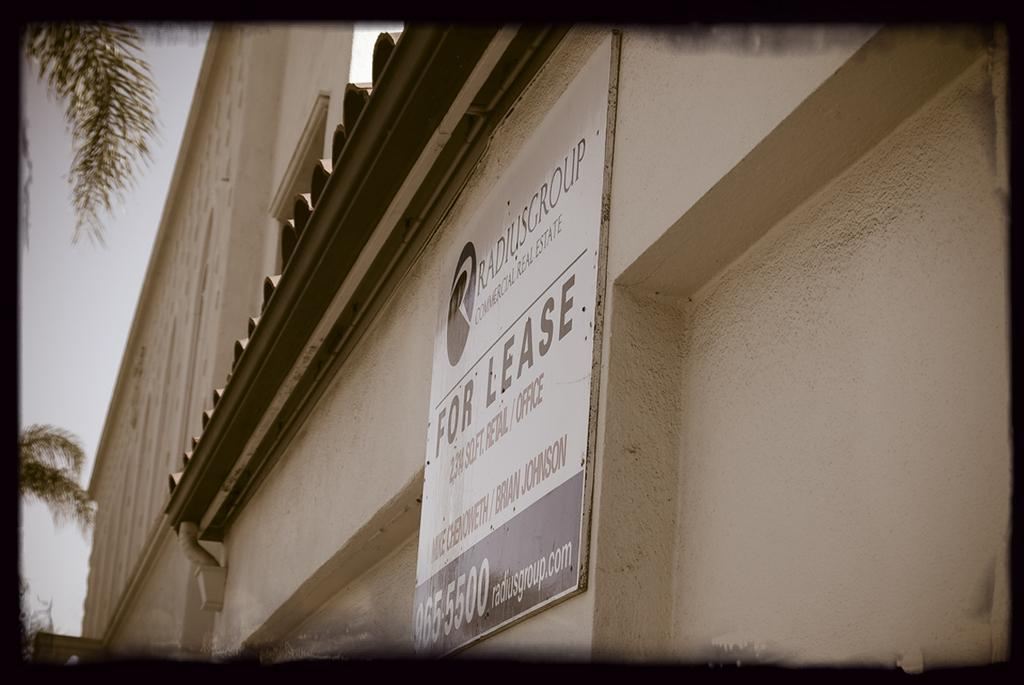What is attached to the wall in the image? There is a board fixed to the wall in the image. What can be found on the board? There is text on the board. What type of structure can be seen in the image? There is a building visible in the image. What is located on the left side of the image? There are trees on the left side of the image. What is visible in the background of the image? The sky is visible in the background of the image. What type of pie is being served in the image? There is no pie present in the image; it features a board with text on a wall. 